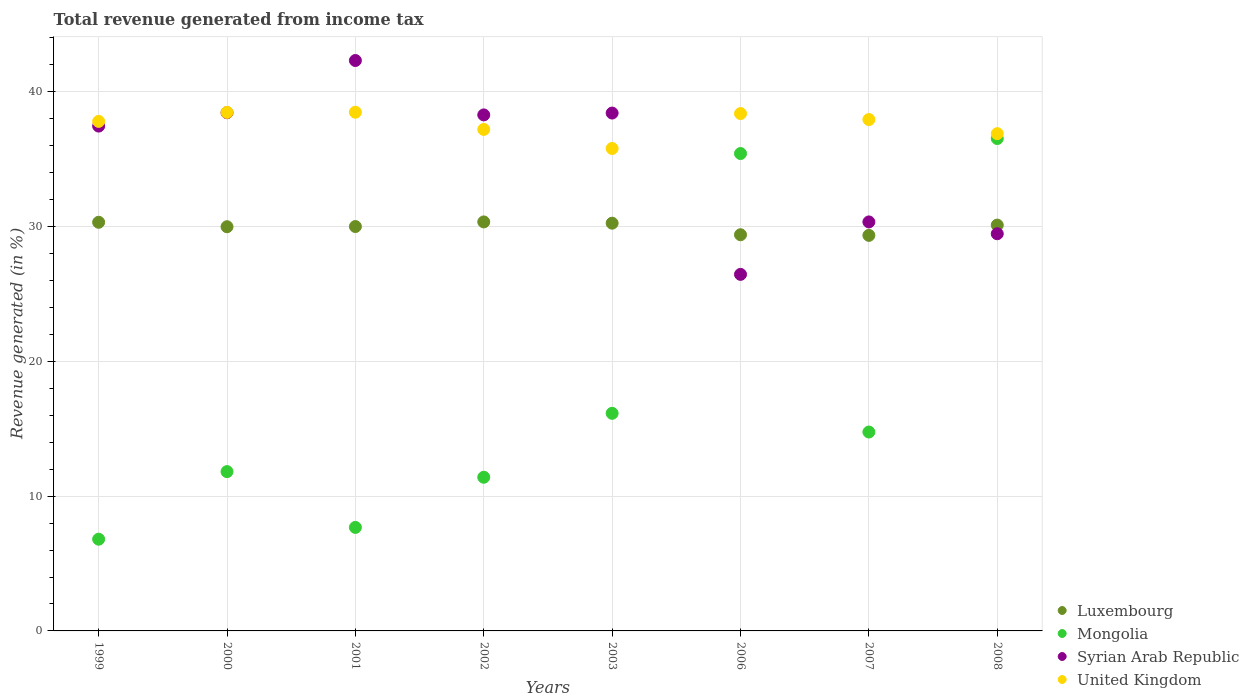How many different coloured dotlines are there?
Ensure brevity in your answer.  4. Is the number of dotlines equal to the number of legend labels?
Ensure brevity in your answer.  Yes. What is the total revenue generated in United Kingdom in 2002?
Your answer should be very brief. 37.2. Across all years, what is the maximum total revenue generated in Syrian Arab Republic?
Offer a very short reply. 42.32. Across all years, what is the minimum total revenue generated in Luxembourg?
Keep it short and to the point. 29.34. What is the total total revenue generated in Luxembourg in the graph?
Your answer should be compact. 239.73. What is the difference between the total revenue generated in Luxembourg in 2000 and that in 2007?
Offer a very short reply. 0.64. What is the difference between the total revenue generated in Mongolia in 2003 and the total revenue generated in Luxembourg in 2008?
Offer a terse response. -13.96. What is the average total revenue generated in Syrian Arab Republic per year?
Your response must be concise. 35.14. In the year 1999, what is the difference between the total revenue generated in Syrian Arab Republic and total revenue generated in Mongolia?
Keep it short and to the point. 30.65. What is the ratio of the total revenue generated in Syrian Arab Republic in 1999 to that in 2002?
Ensure brevity in your answer.  0.98. Is the difference between the total revenue generated in Syrian Arab Republic in 2000 and 2003 greater than the difference between the total revenue generated in Mongolia in 2000 and 2003?
Your response must be concise. Yes. What is the difference between the highest and the second highest total revenue generated in Luxembourg?
Make the answer very short. 0.03. What is the difference between the highest and the lowest total revenue generated in Luxembourg?
Provide a succinct answer. 1. In how many years, is the total revenue generated in Syrian Arab Republic greater than the average total revenue generated in Syrian Arab Republic taken over all years?
Your answer should be very brief. 5. Is the sum of the total revenue generated in Luxembourg in 1999 and 2001 greater than the maximum total revenue generated in Syrian Arab Republic across all years?
Provide a succinct answer. Yes. Is the total revenue generated in Luxembourg strictly less than the total revenue generated in Syrian Arab Republic over the years?
Offer a very short reply. No. How many dotlines are there?
Provide a short and direct response. 4. How are the legend labels stacked?
Provide a short and direct response. Vertical. What is the title of the graph?
Provide a succinct answer. Total revenue generated from income tax. Does "Northern Mariana Islands" appear as one of the legend labels in the graph?
Your answer should be very brief. No. What is the label or title of the Y-axis?
Offer a terse response. Revenue generated (in %). What is the Revenue generated (in %) in Luxembourg in 1999?
Ensure brevity in your answer.  30.32. What is the Revenue generated (in %) of Mongolia in 1999?
Ensure brevity in your answer.  6.8. What is the Revenue generated (in %) in Syrian Arab Republic in 1999?
Your response must be concise. 37.45. What is the Revenue generated (in %) in United Kingdom in 1999?
Make the answer very short. 37.8. What is the Revenue generated (in %) of Luxembourg in 2000?
Provide a succinct answer. 29.98. What is the Revenue generated (in %) of Mongolia in 2000?
Offer a very short reply. 11.82. What is the Revenue generated (in %) in Syrian Arab Republic in 2000?
Offer a terse response. 38.44. What is the Revenue generated (in %) in United Kingdom in 2000?
Provide a succinct answer. 38.46. What is the Revenue generated (in %) of Luxembourg in 2001?
Ensure brevity in your answer.  30. What is the Revenue generated (in %) of Mongolia in 2001?
Make the answer very short. 7.68. What is the Revenue generated (in %) of Syrian Arab Republic in 2001?
Offer a very short reply. 42.32. What is the Revenue generated (in %) in United Kingdom in 2001?
Give a very brief answer. 38.48. What is the Revenue generated (in %) of Luxembourg in 2002?
Offer a terse response. 30.34. What is the Revenue generated (in %) of Mongolia in 2002?
Make the answer very short. 11.4. What is the Revenue generated (in %) of Syrian Arab Republic in 2002?
Your answer should be compact. 38.28. What is the Revenue generated (in %) of United Kingdom in 2002?
Offer a terse response. 37.2. What is the Revenue generated (in %) in Luxembourg in 2003?
Your answer should be compact. 30.25. What is the Revenue generated (in %) of Mongolia in 2003?
Make the answer very short. 16.14. What is the Revenue generated (in %) in Syrian Arab Republic in 2003?
Provide a short and direct response. 38.42. What is the Revenue generated (in %) in United Kingdom in 2003?
Your response must be concise. 35.79. What is the Revenue generated (in %) of Luxembourg in 2006?
Your answer should be very brief. 29.39. What is the Revenue generated (in %) of Mongolia in 2006?
Keep it short and to the point. 35.41. What is the Revenue generated (in %) in Syrian Arab Republic in 2006?
Offer a very short reply. 26.45. What is the Revenue generated (in %) of United Kingdom in 2006?
Your answer should be compact. 38.38. What is the Revenue generated (in %) in Luxembourg in 2007?
Your answer should be very brief. 29.34. What is the Revenue generated (in %) of Mongolia in 2007?
Your answer should be compact. 14.75. What is the Revenue generated (in %) of Syrian Arab Republic in 2007?
Give a very brief answer. 30.34. What is the Revenue generated (in %) in United Kingdom in 2007?
Provide a succinct answer. 37.94. What is the Revenue generated (in %) of Luxembourg in 2008?
Provide a short and direct response. 30.11. What is the Revenue generated (in %) in Mongolia in 2008?
Keep it short and to the point. 36.53. What is the Revenue generated (in %) in Syrian Arab Republic in 2008?
Offer a terse response. 29.46. What is the Revenue generated (in %) of United Kingdom in 2008?
Offer a terse response. 36.89. Across all years, what is the maximum Revenue generated (in %) in Luxembourg?
Your response must be concise. 30.34. Across all years, what is the maximum Revenue generated (in %) of Mongolia?
Keep it short and to the point. 36.53. Across all years, what is the maximum Revenue generated (in %) in Syrian Arab Republic?
Keep it short and to the point. 42.32. Across all years, what is the maximum Revenue generated (in %) in United Kingdom?
Keep it short and to the point. 38.48. Across all years, what is the minimum Revenue generated (in %) of Luxembourg?
Provide a short and direct response. 29.34. Across all years, what is the minimum Revenue generated (in %) of Mongolia?
Provide a succinct answer. 6.8. Across all years, what is the minimum Revenue generated (in %) in Syrian Arab Republic?
Your answer should be very brief. 26.45. Across all years, what is the minimum Revenue generated (in %) in United Kingdom?
Provide a short and direct response. 35.79. What is the total Revenue generated (in %) in Luxembourg in the graph?
Provide a succinct answer. 239.73. What is the total Revenue generated (in %) of Mongolia in the graph?
Your answer should be very brief. 140.54. What is the total Revenue generated (in %) of Syrian Arab Republic in the graph?
Your response must be concise. 281.16. What is the total Revenue generated (in %) in United Kingdom in the graph?
Offer a terse response. 300.94. What is the difference between the Revenue generated (in %) in Luxembourg in 1999 and that in 2000?
Provide a short and direct response. 0.33. What is the difference between the Revenue generated (in %) of Mongolia in 1999 and that in 2000?
Ensure brevity in your answer.  -5.01. What is the difference between the Revenue generated (in %) in Syrian Arab Republic in 1999 and that in 2000?
Offer a terse response. -0.99. What is the difference between the Revenue generated (in %) of United Kingdom in 1999 and that in 2000?
Make the answer very short. -0.67. What is the difference between the Revenue generated (in %) in Luxembourg in 1999 and that in 2001?
Provide a short and direct response. 0.32. What is the difference between the Revenue generated (in %) in Mongolia in 1999 and that in 2001?
Offer a very short reply. -0.87. What is the difference between the Revenue generated (in %) in Syrian Arab Republic in 1999 and that in 2001?
Your answer should be compact. -4.86. What is the difference between the Revenue generated (in %) of United Kingdom in 1999 and that in 2001?
Provide a succinct answer. -0.68. What is the difference between the Revenue generated (in %) of Luxembourg in 1999 and that in 2002?
Provide a succinct answer. -0.03. What is the difference between the Revenue generated (in %) in Mongolia in 1999 and that in 2002?
Make the answer very short. -4.6. What is the difference between the Revenue generated (in %) in Syrian Arab Republic in 1999 and that in 2002?
Give a very brief answer. -0.83. What is the difference between the Revenue generated (in %) of United Kingdom in 1999 and that in 2002?
Offer a terse response. 0.6. What is the difference between the Revenue generated (in %) of Luxembourg in 1999 and that in 2003?
Your response must be concise. 0.07. What is the difference between the Revenue generated (in %) of Mongolia in 1999 and that in 2003?
Give a very brief answer. -9.34. What is the difference between the Revenue generated (in %) in Syrian Arab Republic in 1999 and that in 2003?
Provide a short and direct response. -0.97. What is the difference between the Revenue generated (in %) in United Kingdom in 1999 and that in 2003?
Ensure brevity in your answer.  2.01. What is the difference between the Revenue generated (in %) of Luxembourg in 1999 and that in 2006?
Keep it short and to the point. 0.92. What is the difference between the Revenue generated (in %) of Mongolia in 1999 and that in 2006?
Give a very brief answer. -28.61. What is the difference between the Revenue generated (in %) of Syrian Arab Republic in 1999 and that in 2006?
Offer a very short reply. 11. What is the difference between the Revenue generated (in %) of United Kingdom in 1999 and that in 2006?
Your answer should be very brief. -0.58. What is the difference between the Revenue generated (in %) in Luxembourg in 1999 and that in 2007?
Your response must be concise. 0.97. What is the difference between the Revenue generated (in %) in Mongolia in 1999 and that in 2007?
Your answer should be compact. -7.95. What is the difference between the Revenue generated (in %) in Syrian Arab Republic in 1999 and that in 2007?
Make the answer very short. 7.11. What is the difference between the Revenue generated (in %) in United Kingdom in 1999 and that in 2007?
Your response must be concise. -0.14. What is the difference between the Revenue generated (in %) in Luxembourg in 1999 and that in 2008?
Provide a succinct answer. 0.21. What is the difference between the Revenue generated (in %) of Mongolia in 1999 and that in 2008?
Your answer should be very brief. -29.72. What is the difference between the Revenue generated (in %) in Syrian Arab Republic in 1999 and that in 2008?
Your response must be concise. 7.99. What is the difference between the Revenue generated (in %) in United Kingdom in 1999 and that in 2008?
Provide a short and direct response. 0.91. What is the difference between the Revenue generated (in %) of Luxembourg in 2000 and that in 2001?
Ensure brevity in your answer.  -0.01. What is the difference between the Revenue generated (in %) in Mongolia in 2000 and that in 2001?
Offer a terse response. 4.14. What is the difference between the Revenue generated (in %) of Syrian Arab Republic in 2000 and that in 2001?
Offer a very short reply. -3.87. What is the difference between the Revenue generated (in %) of United Kingdom in 2000 and that in 2001?
Your answer should be very brief. -0.01. What is the difference between the Revenue generated (in %) in Luxembourg in 2000 and that in 2002?
Make the answer very short. -0.36. What is the difference between the Revenue generated (in %) of Mongolia in 2000 and that in 2002?
Your response must be concise. 0.42. What is the difference between the Revenue generated (in %) in Syrian Arab Republic in 2000 and that in 2002?
Provide a short and direct response. 0.16. What is the difference between the Revenue generated (in %) of United Kingdom in 2000 and that in 2002?
Your answer should be very brief. 1.26. What is the difference between the Revenue generated (in %) of Luxembourg in 2000 and that in 2003?
Your response must be concise. -0.26. What is the difference between the Revenue generated (in %) of Mongolia in 2000 and that in 2003?
Provide a succinct answer. -4.33. What is the difference between the Revenue generated (in %) of Syrian Arab Republic in 2000 and that in 2003?
Provide a succinct answer. 0.02. What is the difference between the Revenue generated (in %) of United Kingdom in 2000 and that in 2003?
Ensure brevity in your answer.  2.68. What is the difference between the Revenue generated (in %) of Luxembourg in 2000 and that in 2006?
Keep it short and to the point. 0.59. What is the difference between the Revenue generated (in %) of Mongolia in 2000 and that in 2006?
Give a very brief answer. -23.6. What is the difference between the Revenue generated (in %) in Syrian Arab Republic in 2000 and that in 2006?
Keep it short and to the point. 11.99. What is the difference between the Revenue generated (in %) of United Kingdom in 2000 and that in 2006?
Offer a terse response. 0.08. What is the difference between the Revenue generated (in %) of Luxembourg in 2000 and that in 2007?
Offer a very short reply. 0.64. What is the difference between the Revenue generated (in %) in Mongolia in 2000 and that in 2007?
Offer a very short reply. -2.94. What is the difference between the Revenue generated (in %) of Syrian Arab Republic in 2000 and that in 2007?
Give a very brief answer. 8.1. What is the difference between the Revenue generated (in %) in United Kingdom in 2000 and that in 2007?
Make the answer very short. 0.53. What is the difference between the Revenue generated (in %) in Luxembourg in 2000 and that in 2008?
Offer a terse response. -0.12. What is the difference between the Revenue generated (in %) of Mongolia in 2000 and that in 2008?
Provide a succinct answer. -24.71. What is the difference between the Revenue generated (in %) of Syrian Arab Republic in 2000 and that in 2008?
Make the answer very short. 8.98. What is the difference between the Revenue generated (in %) of United Kingdom in 2000 and that in 2008?
Give a very brief answer. 1.58. What is the difference between the Revenue generated (in %) in Luxembourg in 2001 and that in 2002?
Your answer should be compact. -0.34. What is the difference between the Revenue generated (in %) in Mongolia in 2001 and that in 2002?
Provide a succinct answer. -3.72. What is the difference between the Revenue generated (in %) of Syrian Arab Republic in 2001 and that in 2002?
Offer a very short reply. 4.04. What is the difference between the Revenue generated (in %) in United Kingdom in 2001 and that in 2002?
Provide a succinct answer. 1.28. What is the difference between the Revenue generated (in %) of Luxembourg in 2001 and that in 2003?
Provide a succinct answer. -0.25. What is the difference between the Revenue generated (in %) in Mongolia in 2001 and that in 2003?
Offer a very short reply. -8.46. What is the difference between the Revenue generated (in %) of Syrian Arab Republic in 2001 and that in 2003?
Make the answer very short. 3.9. What is the difference between the Revenue generated (in %) of United Kingdom in 2001 and that in 2003?
Your answer should be very brief. 2.69. What is the difference between the Revenue generated (in %) in Luxembourg in 2001 and that in 2006?
Your answer should be compact. 0.61. What is the difference between the Revenue generated (in %) of Mongolia in 2001 and that in 2006?
Keep it short and to the point. -27.74. What is the difference between the Revenue generated (in %) in Syrian Arab Republic in 2001 and that in 2006?
Keep it short and to the point. 15.87. What is the difference between the Revenue generated (in %) in United Kingdom in 2001 and that in 2006?
Keep it short and to the point. 0.1. What is the difference between the Revenue generated (in %) of Luxembourg in 2001 and that in 2007?
Your answer should be compact. 0.66. What is the difference between the Revenue generated (in %) in Mongolia in 2001 and that in 2007?
Offer a terse response. -7.08. What is the difference between the Revenue generated (in %) of Syrian Arab Republic in 2001 and that in 2007?
Provide a short and direct response. 11.97. What is the difference between the Revenue generated (in %) of United Kingdom in 2001 and that in 2007?
Provide a succinct answer. 0.54. What is the difference between the Revenue generated (in %) of Luxembourg in 2001 and that in 2008?
Provide a succinct answer. -0.11. What is the difference between the Revenue generated (in %) in Mongolia in 2001 and that in 2008?
Your answer should be compact. -28.85. What is the difference between the Revenue generated (in %) of Syrian Arab Republic in 2001 and that in 2008?
Make the answer very short. 12.85. What is the difference between the Revenue generated (in %) in United Kingdom in 2001 and that in 2008?
Your answer should be very brief. 1.59. What is the difference between the Revenue generated (in %) of Luxembourg in 2002 and that in 2003?
Provide a short and direct response. 0.09. What is the difference between the Revenue generated (in %) of Mongolia in 2002 and that in 2003?
Provide a short and direct response. -4.74. What is the difference between the Revenue generated (in %) in Syrian Arab Republic in 2002 and that in 2003?
Keep it short and to the point. -0.14. What is the difference between the Revenue generated (in %) in United Kingdom in 2002 and that in 2003?
Provide a succinct answer. 1.41. What is the difference between the Revenue generated (in %) of Luxembourg in 2002 and that in 2006?
Provide a succinct answer. 0.95. What is the difference between the Revenue generated (in %) in Mongolia in 2002 and that in 2006?
Provide a succinct answer. -24.01. What is the difference between the Revenue generated (in %) in Syrian Arab Republic in 2002 and that in 2006?
Your answer should be compact. 11.83. What is the difference between the Revenue generated (in %) in United Kingdom in 2002 and that in 2006?
Your response must be concise. -1.18. What is the difference between the Revenue generated (in %) of Mongolia in 2002 and that in 2007?
Make the answer very short. -3.36. What is the difference between the Revenue generated (in %) in Syrian Arab Republic in 2002 and that in 2007?
Provide a short and direct response. 7.94. What is the difference between the Revenue generated (in %) in United Kingdom in 2002 and that in 2007?
Your answer should be very brief. -0.73. What is the difference between the Revenue generated (in %) of Luxembourg in 2002 and that in 2008?
Give a very brief answer. 0.24. What is the difference between the Revenue generated (in %) of Mongolia in 2002 and that in 2008?
Make the answer very short. -25.13. What is the difference between the Revenue generated (in %) of Syrian Arab Republic in 2002 and that in 2008?
Provide a succinct answer. 8.82. What is the difference between the Revenue generated (in %) in United Kingdom in 2002 and that in 2008?
Your response must be concise. 0.31. What is the difference between the Revenue generated (in %) in Luxembourg in 2003 and that in 2006?
Your response must be concise. 0.86. What is the difference between the Revenue generated (in %) in Mongolia in 2003 and that in 2006?
Ensure brevity in your answer.  -19.27. What is the difference between the Revenue generated (in %) of Syrian Arab Republic in 2003 and that in 2006?
Keep it short and to the point. 11.97. What is the difference between the Revenue generated (in %) in United Kingdom in 2003 and that in 2006?
Make the answer very short. -2.59. What is the difference between the Revenue generated (in %) in Luxembourg in 2003 and that in 2007?
Offer a terse response. 0.9. What is the difference between the Revenue generated (in %) of Mongolia in 2003 and that in 2007?
Offer a very short reply. 1.39. What is the difference between the Revenue generated (in %) in Syrian Arab Republic in 2003 and that in 2007?
Give a very brief answer. 8.08. What is the difference between the Revenue generated (in %) of United Kingdom in 2003 and that in 2007?
Offer a very short reply. -2.15. What is the difference between the Revenue generated (in %) of Luxembourg in 2003 and that in 2008?
Give a very brief answer. 0.14. What is the difference between the Revenue generated (in %) of Mongolia in 2003 and that in 2008?
Provide a succinct answer. -20.39. What is the difference between the Revenue generated (in %) of Syrian Arab Republic in 2003 and that in 2008?
Offer a very short reply. 8.95. What is the difference between the Revenue generated (in %) of United Kingdom in 2003 and that in 2008?
Give a very brief answer. -1.1. What is the difference between the Revenue generated (in %) of Luxembourg in 2006 and that in 2007?
Keep it short and to the point. 0.05. What is the difference between the Revenue generated (in %) of Mongolia in 2006 and that in 2007?
Your response must be concise. 20.66. What is the difference between the Revenue generated (in %) in Syrian Arab Republic in 2006 and that in 2007?
Keep it short and to the point. -3.89. What is the difference between the Revenue generated (in %) of United Kingdom in 2006 and that in 2007?
Give a very brief answer. 0.44. What is the difference between the Revenue generated (in %) in Luxembourg in 2006 and that in 2008?
Offer a very short reply. -0.72. What is the difference between the Revenue generated (in %) in Mongolia in 2006 and that in 2008?
Provide a succinct answer. -1.11. What is the difference between the Revenue generated (in %) in Syrian Arab Republic in 2006 and that in 2008?
Offer a terse response. -3.01. What is the difference between the Revenue generated (in %) in United Kingdom in 2006 and that in 2008?
Provide a short and direct response. 1.49. What is the difference between the Revenue generated (in %) of Luxembourg in 2007 and that in 2008?
Your response must be concise. -0.76. What is the difference between the Revenue generated (in %) in Mongolia in 2007 and that in 2008?
Make the answer very short. -21.77. What is the difference between the Revenue generated (in %) in Syrian Arab Republic in 2007 and that in 2008?
Your answer should be very brief. 0.88. What is the difference between the Revenue generated (in %) of United Kingdom in 2007 and that in 2008?
Provide a succinct answer. 1.05. What is the difference between the Revenue generated (in %) in Luxembourg in 1999 and the Revenue generated (in %) in Mongolia in 2000?
Your answer should be very brief. 18.5. What is the difference between the Revenue generated (in %) in Luxembourg in 1999 and the Revenue generated (in %) in Syrian Arab Republic in 2000?
Make the answer very short. -8.13. What is the difference between the Revenue generated (in %) of Luxembourg in 1999 and the Revenue generated (in %) of United Kingdom in 2000?
Your answer should be very brief. -8.15. What is the difference between the Revenue generated (in %) of Mongolia in 1999 and the Revenue generated (in %) of Syrian Arab Republic in 2000?
Offer a very short reply. -31.64. What is the difference between the Revenue generated (in %) in Mongolia in 1999 and the Revenue generated (in %) in United Kingdom in 2000?
Your response must be concise. -31.66. What is the difference between the Revenue generated (in %) in Syrian Arab Republic in 1999 and the Revenue generated (in %) in United Kingdom in 2000?
Your response must be concise. -1.01. What is the difference between the Revenue generated (in %) of Luxembourg in 1999 and the Revenue generated (in %) of Mongolia in 2001?
Make the answer very short. 22.64. What is the difference between the Revenue generated (in %) in Luxembourg in 1999 and the Revenue generated (in %) in Syrian Arab Republic in 2001?
Keep it short and to the point. -12. What is the difference between the Revenue generated (in %) in Luxembourg in 1999 and the Revenue generated (in %) in United Kingdom in 2001?
Make the answer very short. -8.16. What is the difference between the Revenue generated (in %) of Mongolia in 1999 and the Revenue generated (in %) of Syrian Arab Republic in 2001?
Provide a succinct answer. -35.51. What is the difference between the Revenue generated (in %) in Mongolia in 1999 and the Revenue generated (in %) in United Kingdom in 2001?
Your response must be concise. -31.67. What is the difference between the Revenue generated (in %) in Syrian Arab Republic in 1999 and the Revenue generated (in %) in United Kingdom in 2001?
Provide a short and direct response. -1.03. What is the difference between the Revenue generated (in %) of Luxembourg in 1999 and the Revenue generated (in %) of Mongolia in 2002?
Provide a succinct answer. 18.92. What is the difference between the Revenue generated (in %) in Luxembourg in 1999 and the Revenue generated (in %) in Syrian Arab Republic in 2002?
Provide a succinct answer. -7.96. What is the difference between the Revenue generated (in %) of Luxembourg in 1999 and the Revenue generated (in %) of United Kingdom in 2002?
Your answer should be very brief. -6.89. What is the difference between the Revenue generated (in %) in Mongolia in 1999 and the Revenue generated (in %) in Syrian Arab Republic in 2002?
Make the answer very short. -31.48. What is the difference between the Revenue generated (in %) in Mongolia in 1999 and the Revenue generated (in %) in United Kingdom in 2002?
Provide a short and direct response. -30.4. What is the difference between the Revenue generated (in %) of Syrian Arab Republic in 1999 and the Revenue generated (in %) of United Kingdom in 2002?
Provide a short and direct response. 0.25. What is the difference between the Revenue generated (in %) of Luxembourg in 1999 and the Revenue generated (in %) of Mongolia in 2003?
Offer a very short reply. 14.17. What is the difference between the Revenue generated (in %) of Luxembourg in 1999 and the Revenue generated (in %) of Syrian Arab Republic in 2003?
Your answer should be compact. -8.1. What is the difference between the Revenue generated (in %) of Luxembourg in 1999 and the Revenue generated (in %) of United Kingdom in 2003?
Ensure brevity in your answer.  -5.47. What is the difference between the Revenue generated (in %) in Mongolia in 1999 and the Revenue generated (in %) in Syrian Arab Republic in 2003?
Offer a terse response. -31.61. What is the difference between the Revenue generated (in %) of Mongolia in 1999 and the Revenue generated (in %) of United Kingdom in 2003?
Give a very brief answer. -28.99. What is the difference between the Revenue generated (in %) of Syrian Arab Republic in 1999 and the Revenue generated (in %) of United Kingdom in 2003?
Provide a short and direct response. 1.66. What is the difference between the Revenue generated (in %) of Luxembourg in 1999 and the Revenue generated (in %) of Mongolia in 2006?
Make the answer very short. -5.1. What is the difference between the Revenue generated (in %) in Luxembourg in 1999 and the Revenue generated (in %) in Syrian Arab Republic in 2006?
Make the answer very short. 3.87. What is the difference between the Revenue generated (in %) in Luxembourg in 1999 and the Revenue generated (in %) in United Kingdom in 2006?
Your answer should be compact. -8.07. What is the difference between the Revenue generated (in %) in Mongolia in 1999 and the Revenue generated (in %) in Syrian Arab Republic in 2006?
Your answer should be compact. -19.65. What is the difference between the Revenue generated (in %) in Mongolia in 1999 and the Revenue generated (in %) in United Kingdom in 2006?
Ensure brevity in your answer.  -31.58. What is the difference between the Revenue generated (in %) in Syrian Arab Republic in 1999 and the Revenue generated (in %) in United Kingdom in 2006?
Offer a terse response. -0.93. What is the difference between the Revenue generated (in %) in Luxembourg in 1999 and the Revenue generated (in %) in Mongolia in 2007?
Provide a succinct answer. 15.56. What is the difference between the Revenue generated (in %) in Luxembourg in 1999 and the Revenue generated (in %) in Syrian Arab Republic in 2007?
Your response must be concise. -0.03. What is the difference between the Revenue generated (in %) in Luxembourg in 1999 and the Revenue generated (in %) in United Kingdom in 2007?
Your answer should be compact. -7.62. What is the difference between the Revenue generated (in %) in Mongolia in 1999 and the Revenue generated (in %) in Syrian Arab Republic in 2007?
Your answer should be compact. -23.54. What is the difference between the Revenue generated (in %) in Mongolia in 1999 and the Revenue generated (in %) in United Kingdom in 2007?
Make the answer very short. -31.13. What is the difference between the Revenue generated (in %) of Syrian Arab Republic in 1999 and the Revenue generated (in %) of United Kingdom in 2007?
Give a very brief answer. -0.49. What is the difference between the Revenue generated (in %) in Luxembourg in 1999 and the Revenue generated (in %) in Mongolia in 2008?
Your answer should be compact. -6.21. What is the difference between the Revenue generated (in %) in Luxembourg in 1999 and the Revenue generated (in %) in Syrian Arab Republic in 2008?
Your answer should be compact. 0.85. What is the difference between the Revenue generated (in %) in Luxembourg in 1999 and the Revenue generated (in %) in United Kingdom in 2008?
Offer a very short reply. -6.57. What is the difference between the Revenue generated (in %) of Mongolia in 1999 and the Revenue generated (in %) of Syrian Arab Republic in 2008?
Give a very brief answer. -22.66. What is the difference between the Revenue generated (in %) of Mongolia in 1999 and the Revenue generated (in %) of United Kingdom in 2008?
Offer a very short reply. -30.09. What is the difference between the Revenue generated (in %) of Syrian Arab Republic in 1999 and the Revenue generated (in %) of United Kingdom in 2008?
Your answer should be compact. 0.56. What is the difference between the Revenue generated (in %) of Luxembourg in 2000 and the Revenue generated (in %) of Mongolia in 2001?
Ensure brevity in your answer.  22.31. What is the difference between the Revenue generated (in %) of Luxembourg in 2000 and the Revenue generated (in %) of Syrian Arab Republic in 2001?
Provide a succinct answer. -12.33. What is the difference between the Revenue generated (in %) in Luxembourg in 2000 and the Revenue generated (in %) in United Kingdom in 2001?
Your answer should be very brief. -8.49. What is the difference between the Revenue generated (in %) of Mongolia in 2000 and the Revenue generated (in %) of Syrian Arab Republic in 2001?
Your answer should be compact. -30.5. What is the difference between the Revenue generated (in %) in Mongolia in 2000 and the Revenue generated (in %) in United Kingdom in 2001?
Your answer should be compact. -26.66. What is the difference between the Revenue generated (in %) in Syrian Arab Republic in 2000 and the Revenue generated (in %) in United Kingdom in 2001?
Make the answer very short. -0.04. What is the difference between the Revenue generated (in %) of Luxembourg in 2000 and the Revenue generated (in %) of Mongolia in 2002?
Keep it short and to the point. 18.59. What is the difference between the Revenue generated (in %) in Luxembourg in 2000 and the Revenue generated (in %) in Syrian Arab Republic in 2002?
Your answer should be very brief. -8.3. What is the difference between the Revenue generated (in %) in Luxembourg in 2000 and the Revenue generated (in %) in United Kingdom in 2002?
Give a very brief answer. -7.22. What is the difference between the Revenue generated (in %) in Mongolia in 2000 and the Revenue generated (in %) in Syrian Arab Republic in 2002?
Ensure brevity in your answer.  -26.46. What is the difference between the Revenue generated (in %) in Mongolia in 2000 and the Revenue generated (in %) in United Kingdom in 2002?
Keep it short and to the point. -25.39. What is the difference between the Revenue generated (in %) in Syrian Arab Republic in 2000 and the Revenue generated (in %) in United Kingdom in 2002?
Provide a succinct answer. 1.24. What is the difference between the Revenue generated (in %) of Luxembourg in 2000 and the Revenue generated (in %) of Mongolia in 2003?
Offer a very short reply. 13.84. What is the difference between the Revenue generated (in %) in Luxembourg in 2000 and the Revenue generated (in %) in Syrian Arab Republic in 2003?
Offer a very short reply. -8.43. What is the difference between the Revenue generated (in %) in Luxembourg in 2000 and the Revenue generated (in %) in United Kingdom in 2003?
Provide a succinct answer. -5.81. What is the difference between the Revenue generated (in %) of Mongolia in 2000 and the Revenue generated (in %) of Syrian Arab Republic in 2003?
Ensure brevity in your answer.  -26.6. What is the difference between the Revenue generated (in %) of Mongolia in 2000 and the Revenue generated (in %) of United Kingdom in 2003?
Ensure brevity in your answer.  -23.97. What is the difference between the Revenue generated (in %) in Syrian Arab Republic in 2000 and the Revenue generated (in %) in United Kingdom in 2003?
Your answer should be compact. 2.65. What is the difference between the Revenue generated (in %) in Luxembourg in 2000 and the Revenue generated (in %) in Mongolia in 2006?
Provide a short and direct response. -5.43. What is the difference between the Revenue generated (in %) of Luxembourg in 2000 and the Revenue generated (in %) of Syrian Arab Republic in 2006?
Offer a terse response. 3.53. What is the difference between the Revenue generated (in %) in Luxembourg in 2000 and the Revenue generated (in %) in United Kingdom in 2006?
Give a very brief answer. -8.4. What is the difference between the Revenue generated (in %) in Mongolia in 2000 and the Revenue generated (in %) in Syrian Arab Republic in 2006?
Your answer should be very brief. -14.63. What is the difference between the Revenue generated (in %) of Mongolia in 2000 and the Revenue generated (in %) of United Kingdom in 2006?
Ensure brevity in your answer.  -26.56. What is the difference between the Revenue generated (in %) in Syrian Arab Republic in 2000 and the Revenue generated (in %) in United Kingdom in 2006?
Offer a very short reply. 0.06. What is the difference between the Revenue generated (in %) of Luxembourg in 2000 and the Revenue generated (in %) of Mongolia in 2007?
Offer a very short reply. 15.23. What is the difference between the Revenue generated (in %) of Luxembourg in 2000 and the Revenue generated (in %) of Syrian Arab Republic in 2007?
Your response must be concise. -0.36. What is the difference between the Revenue generated (in %) of Luxembourg in 2000 and the Revenue generated (in %) of United Kingdom in 2007?
Give a very brief answer. -7.95. What is the difference between the Revenue generated (in %) in Mongolia in 2000 and the Revenue generated (in %) in Syrian Arab Republic in 2007?
Make the answer very short. -18.52. What is the difference between the Revenue generated (in %) of Mongolia in 2000 and the Revenue generated (in %) of United Kingdom in 2007?
Make the answer very short. -26.12. What is the difference between the Revenue generated (in %) of Syrian Arab Republic in 2000 and the Revenue generated (in %) of United Kingdom in 2007?
Offer a very short reply. 0.5. What is the difference between the Revenue generated (in %) of Luxembourg in 2000 and the Revenue generated (in %) of Mongolia in 2008?
Offer a very short reply. -6.54. What is the difference between the Revenue generated (in %) of Luxembourg in 2000 and the Revenue generated (in %) of Syrian Arab Republic in 2008?
Ensure brevity in your answer.  0.52. What is the difference between the Revenue generated (in %) of Luxembourg in 2000 and the Revenue generated (in %) of United Kingdom in 2008?
Offer a very short reply. -6.91. What is the difference between the Revenue generated (in %) in Mongolia in 2000 and the Revenue generated (in %) in Syrian Arab Republic in 2008?
Offer a terse response. -17.65. What is the difference between the Revenue generated (in %) in Mongolia in 2000 and the Revenue generated (in %) in United Kingdom in 2008?
Offer a terse response. -25.07. What is the difference between the Revenue generated (in %) in Syrian Arab Republic in 2000 and the Revenue generated (in %) in United Kingdom in 2008?
Ensure brevity in your answer.  1.55. What is the difference between the Revenue generated (in %) in Luxembourg in 2001 and the Revenue generated (in %) in Mongolia in 2002?
Give a very brief answer. 18.6. What is the difference between the Revenue generated (in %) of Luxembourg in 2001 and the Revenue generated (in %) of Syrian Arab Republic in 2002?
Your answer should be compact. -8.28. What is the difference between the Revenue generated (in %) in Luxembourg in 2001 and the Revenue generated (in %) in United Kingdom in 2002?
Provide a short and direct response. -7.2. What is the difference between the Revenue generated (in %) of Mongolia in 2001 and the Revenue generated (in %) of Syrian Arab Republic in 2002?
Provide a short and direct response. -30.6. What is the difference between the Revenue generated (in %) of Mongolia in 2001 and the Revenue generated (in %) of United Kingdom in 2002?
Ensure brevity in your answer.  -29.52. What is the difference between the Revenue generated (in %) of Syrian Arab Republic in 2001 and the Revenue generated (in %) of United Kingdom in 2002?
Keep it short and to the point. 5.11. What is the difference between the Revenue generated (in %) in Luxembourg in 2001 and the Revenue generated (in %) in Mongolia in 2003?
Your answer should be compact. 13.86. What is the difference between the Revenue generated (in %) in Luxembourg in 2001 and the Revenue generated (in %) in Syrian Arab Republic in 2003?
Provide a succinct answer. -8.42. What is the difference between the Revenue generated (in %) in Luxembourg in 2001 and the Revenue generated (in %) in United Kingdom in 2003?
Offer a very short reply. -5.79. What is the difference between the Revenue generated (in %) of Mongolia in 2001 and the Revenue generated (in %) of Syrian Arab Republic in 2003?
Ensure brevity in your answer.  -30.74. What is the difference between the Revenue generated (in %) in Mongolia in 2001 and the Revenue generated (in %) in United Kingdom in 2003?
Make the answer very short. -28.11. What is the difference between the Revenue generated (in %) of Syrian Arab Republic in 2001 and the Revenue generated (in %) of United Kingdom in 2003?
Provide a short and direct response. 6.53. What is the difference between the Revenue generated (in %) in Luxembourg in 2001 and the Revenue generated (in %) in Mongolia in 2006?
Offer a very short reply. -5.42. What is the difference between the Revenue generated (in %) in Luxembourg in 2001 and the Revenue generated (in %) in Syrian Arab Republic in 2006?
Provide a short and direct response. 3.55. What is the difference between the Revenue generated (in %) of Luxembourg in 2001 and the Revenue generated (in %) of United Kingdom in 2006?
Ensure brevity in your answer.  -8.38. What is the difference between the Revenue generated (in %) of Mongolia in 2001 and the Revenue generated (in %) of Syrian Arab Republic in 2006?
Give a very brief answer. -18.77. What is the difference between the Revenue generated (in %) in Mongolia in 2001 and the Revenue generated (in %) in United Kingdom in 2006?
Give a very brief answer. -30.7. What is the difference between the Revenue generated (in %) in Syrian Arab Republic in 2001 and the Revenue generated (in %) in United Kingdom in 2006?
Provide a succinct answer. 3.93. What is the difference between the Revenue generated (in %) in Luxembourg in 2001 and the Revenue generated (in %) in Mongolia in 2007?
Make the answer very short. 15.24. What is the difference between the Revenue generated (in %) of Luxembourg in 2001 and the Revenue generated (in %) of Syrian Arab Republic in 2007?
Your answer should be very brief. -0.34. What is the difference between the Revenue generated (in %) in Luxembourg in 2001 and the Revenue generated (in %) in United Kingdom in 2007?
Offer a terse response. -7.94. What is the difference between the Revenue generated (in %) of Mongolia in 2001 and the Revenue generated (in %) of Syrian Arab Republic in 2007?
Offer a very short reply. -22.66. What is the difference between the Revenue generated (in %) in Mongolia in 2001 and the Revenue generated (in %) in United Kingdom in 2007?
Offer a terse response. -30.26. What is the difference between the Revenue generated (in %) of Syrian Arab Republic in 2001 and the Revenue generated (in %) of United Kingdom in 2007?
Give a very brief answer. 4.38. What is the difference between the Revenue generated (in %) in Luxembourg in 2001 and the Revenue generated (in %) in Mongolia in 2008?
Offer a terse response. -6.53. What is the difference between the Revenue generated (in %) of Luxembourg in 2001 and the Revenue generated (in %) of Syrian Arab Republic in 2008?
Make the answer very short. 0.53. What is the difference between the Revenue generated (in %) of Luxembourg in 2001 and the Revenue generated (in %) of United Kingdom in 2008?
Offer a terse response. -6.89. What is the difference between the Revenue generated (in %) of Mongolia in 2001 and the Revenue generated (in %) of Syrian Arab Republic in 2008?
Provide a succinct answer. -21.79. What is the difference between the Revenue generated (in %) of Mongolia in 2001 and the Revenue generated (in %) of United Kingdom in 2008?
Keep it short and to the point. -29.21. What is the difference between the Revenue generated (in %) of Syrian Arab Republic in 2001 and the Revenue generated (in %) of United Kingdom in 2008?
Give a very brief answer. 5.43. What is the difference between the Revenue generated (in %) in Luxembourg in 2002 and the Revenue generated (in %) in Mongolia in 2003?
Your answer should be compact. 14.2. What is the difference between the Revenue generated (in %) in Luxembourg in 2002 and the Revenue generated (in %) in Syrian Arab Republic in 2003?
Your response must be concise. -8.07. What is the difference between the Revenue generated (in %) of Luxembourg in 2002 and the Revenue generated (in %) of United Kingdom in 2003?
Provide a succinct answer. -5.45. What is the difference between the Revenue generated (in %) of Mongolia in 2002 and the Revenue generated (in %) of Syrian Arab Republic in 2003?
Keep it short and to the point. -27.02. What is the difference between the Revenue generated (in %) of Mongolia in 2002 and the Revenue generated (in %) of United Kingdom in 2003?
Your response must be concise. -24.39. What is the difference between the Revenue generated (in %) of Syrian Arab Republic in 2002 and the Revenue generated (in %) of United Kingdom in 2003?
Offer a very short reply. 2.49. What is the difference between the Revenue generated (in %) in Luxembourg in 2002 and the Revenue generated (in %) in Mongolia in 2006?
Ensure brevity in your answer.  -5.07. What is the difference between the Revenue generated (in %) in Luxembourg in 2002 and the Revenue generated (in %) in Syrian Arab Republic in 2006?
Give a very brief answer. 3.89. What is the difference between the Revenue generated (in %) of Luxembourg in 2002 and the Revenue generated (in %) of United Kingdom in 2006?
Offer a very short reply. -8.04. What is the difference between the Revenue generated (in %) of Mongolia in 2002 and the Revenue generated (in %) of Syrian Arab Republic in 2006?
Offer a terse response. -15.05. What is the difference between the Revenue generated (in %) of Mongolia in 2002 and the Revenue generated (in %) of United Kingdom in 2006?
Give a very brief answer. -26.98. What is the difference between the Revenue generated (in %) in Syrian Arab Republic in 2002 and the Revenue generated (in %) in United Kingdom in 2006?
Your response must be concise. -0.1. What is the difference between the Revenue generated (in %) of Luxembourg in 2002 and the Revenue generated (in %) of Mongolia in 2007?
Your response must be concise. 15.59. What is the difference between the Revenue generated (in %) in Luxembourg in 2002 and the Revenue generated (in %) in Syrian Arab Republic in 2007?
Provide a short and direct response. 0. What is the difference between the Revenue generated (in %) in Luxembourg in 2002 and the Revenue generated (in %) in United Kingdom in 2007?
Keep it short and to the point. -7.59. What is the difference between the Revenue generated (in %) of Mongolia in 2002 and the Revenue generated (in %) of Syrian Arab Republic in 2007?
Keep it short and to the point. -18.94. What is the difference between the Revenue generated (in %) of Mongolia in 2002 and the Revenue generated (in %) of United Kingdom in 2007?
Give a very brief answer. -26.54. What is the difference between the Revenue generated (in %) of Syrian Arab Republic in 2002 and the Revenue generated (in %) of United Kingdom in 2007?
Your answer should be compact. 0.34. What is the difference between the Revenue generated (in %) in Luxembourg in 2002 and the Revenue generated (in %) in Mongolia in 2008?
Provide a succinct answer. -6.19. What is the difference between the Revenue generated (in %) of Luxembourg in 2002 and the Revenue generated (in %) of Syrian Arab Republic in 2008?
Your answer should be compact. 0.88. What is the difference between the Revenue generated (in %) of Luxembourg in 2002 and the Revenue generated (in %) of United Kingdom in 2008?
Your answer should be very brief. -6.55. What is the difference between the Revenue generated (in %) in Mongolia in 2002 and the Revenue generated (in %) in Syrian Arab Republic in 2008?
Provide a short and direct response. -18.06. What is the difference between the Revenue generated (in %) in Mongolia in 2002 and the Revenue generated (in %) in United Kingdom in 2008?
Your answer should be very brief. -25.49. What is the difference between the Revenue generated (in %) of Syrian Arab Republic in 2002 and the Revenue generated (in %) of United Kingdom in 2008?
Offer a terse response. 1.39. What is the difference between the Revenue generated (in %) in Luxembourg in 2003 and the Revenue generated (in %) in Mongolia in 2006?
Your answer should be compact. -5.17. What is the difference between the Revenue generated (in %) of Luxembourg in 2003 and the Revenue generated (in %) of Syrian Arab Republic in 2006?
Provide a succinct answer. 3.8. What is the difference between the Revenue generated (in %) in Luxembourg in 2003 and the Revenue generated (in %) in United Kingdom in 2006?
Keep it short and to the point. -8.13. What is the difference between the Revenue generated (in %) of Mongolia in 2003 and the Revenue generated (in %) of Syrian Arab Republic in 2006?
Ensure brevity in your answer.  -10.31. What is the difference between the Revenue generated (in %) in Mongolia in 2003 and the Revenue generated (in %) in United Kingdom in 2006?
Offer a terse response. -22.24. What is the difference between the Revenue generated (in %) in Syrian Arab Republic in 2003 and the Revenue generated (in %) in United Kingdom in 2006?
Keep it short and to the point. 0.04. What is the difference between the Revenue generated (in %) in Luxembourg in 2003 and the Revenue generated (in %) in Mongolia in 2007?
Offer a very short reply. 15.49. What is the difference between the Revenue generated (in %) of Luxembourg in 2003 and the Revenue generated (in %) of Syrian Arab Republic in 2007?
Make the answer very short. -0.09. What is the difference between the Revenue generated (in %) of Luxembourg in 2003 and the Revenue generated (in %) of United Kingdom in 2007?
Offer a very short reply. -7.69. What is the difference between the Revenue generated (in %) of Mongolia in 2003 and the Revenue generated (in %) of Syrian Arab Republic in 2007?
Keep it short and to the point. -14.2. What is the difference between the Revenue generated (in %) of Mongolia in 2003 and the Revenue generated (in %) of United Kingdom in 2007?
Your answer should be compact. -21.79. What is the difference between the Revenue generated (in %) in Syrian Arab Republic in 2003 and the Revenue generated (in %) in United Kingdom in 2007?
Give a very brief answer. 0.48. What is the difference between the Revenue generated (in %) of Luxembourg in 2003 and the Revenue generated (in %) of Mongolia in 2008?
Your answer should be very brief. -6.28. What is the difference between the Revenue generated (in %) in Luxembourg in 2003 and the Revenue generated (in %) in Syrian Arab Republic in 2008?
Keep it short and to the point. 0.78. What is the difference between the Revenue generated (in %) of Luxembourg in 2003 and the Revenue generated (in %) of United Kingdom in 2008?
Your response must be concise. -6.64. What is the difference between the Revenue generated (in %) in Mongolia in 2003 and the Revenue generated (in %) in Syrian Arab Republic in 2008?
Offer a very short reply. -13.32. What is the difference between the Revenue generated (in %) of Mongolia in 2003 and the Revenue generated (in %) of United Kingdom in 2008?
Offer a very short reply. -20.75. What is the difference between the Revenue generated (in %) of Syrian Arab Republic in 2003 and the Revenue generated (in %) of United Kingdom in 2008?
Provide a succinct answer. 1.53. What is the difference between the Revenue generated (in %) of Luxembourg in 2006 and the Revenue generated (in %) of Mongolia in 2007?
Provide a short and direct response. 14.64. What is the difference between the Revenue generated (in %) of Luxembourg in 2006 and the Revenue generated (in %) of Syrian Arab Republic in 2007?
Your answer should be very brief. -0.95. What is the difference between the Revenue generated (in %) in Luxembourg in 2006 and the Revenue generated (in %) in United Kingdom in 2007?
Your response must be concise. -8.55. What is the difference between the Revenue generated (in %) of Mongolia in 2006 and the Revenue generated (in %) of Syrian Arab Republic in 2007?
Provide a succinct answer. 5.07. What is the difference between the Revenue generated (in %) in Mongolia in 2006 and the Revenue generated (in %) in United Kingdom in 2007?
Offer a terse response. -2.52. What is the difference between the Revenue generated (in %) of Syrian Arab Republic in 2006 and the Revenue generated (in %) of United Kingdom in 2007?
Offer a terse response. -11.49. What is the difference between the Revenue generated (in %) in Luxembourg in 2006 and the Revenue generated (in %) in Mongolia in 2008?
Make the answer very short. -7.14. What is the difference between the Revenue generated (in %) in Luxembourg in 2006 and the Revenue generated (in %) in Syrian Arab Republic in 2008?
Keep it short and to the point. -0.07. What is the difference between the Revenue generated (in %) of Luxembourg in 2006 and the Revenue generated (in %) of United Kingdom in 2008?
Offer a terse response. -7.5. What is the difference between the Revenue generated (in %) in Mongolia in 2006 and the Revenue generated (in %) in Syrian Arab Republic in 2008?
Your answer should be compact. 5.95. What is the difference between the Revenue generated (in %) in Mongolia in 2006 and the Revenue generated (in %) in United Kingdom in 2008?
Provide a succinct answer. -1.48. What is the difference between the Revenue generated (in %) of Syrian Arab Republic in 2006 and the Revenue generated (in %) of United Kingdom in 2008?
Provide a succinct answer. -10.44. What is the difference between the Revenue generated (in %) in Luxembourg in 2007 and the Revenue generated (in %) in Mongolia in 2008?
Your response must be concise. -7.18. What is the difference between the Revenue generated (in %) in Luxembourg in 2007 and the Revenue generated (in %) in Syrian Arab Republic in 2008?
Provide a succinct answer. -0.12. What is the difference between the Revenue generated (in %) in Luxembourg in 2007 and the Revenue generated (in %) in United Kingdom in 2008?
Provide a short and direct response. -7.55. What is the difference between the Revenue generated (in %) of Mongolia in 2007 and the Revenue generated (in %) of Syrian Arab Republic in 2008?
Make the answer very short. -14.71. What is the difference between the Revenue generated (in %) of Mongolia in 2007 and the Revenue generated (in %) of United Kingdom in 2008?
Provide a succinct answer. -22.14. What is the difference between the Revenue generated (in %) in Syrian Arab Republic in 2007 and the Revenue generated (in %) in United Kingdom in 2008?
Provide a short and direct response. -6.55. What is the average Revenue generated (in %) in Luxembourg per year?
Your answer should be compact. 29.97. What is the average Revenue generated (in %) in Mongolia per year?
Provide a succinct answer. 17.57. What is the average Revenue generated (in %) in Syrian Arab Republic per year?
Provide a succinct answer. 35.14. What is the average Revenue generated (in %) in United Kingdom per year?
Ensure brevity in your answer.  37.62. In the year 1999, what is the difference between the Revenue generated (in %) of Luxembourg and Revenue generated (in %) of Mongolia?
Your response must be concise. 23.51. In the year 1999, what is the difference between the Revenue generated (in %) in Luxembourg and Revenue generated (in %) in Syrian Arab Republic?
Your answer should be compact. -7.14. In the year 1999, what is the difference between the Revenue generated (in %) in Luxembourg and Revenue generated (in %) in United Kingdom?
Ensure brevity in your answer.  -7.48. In the year 1999, what is the difference between the Revenue generated (in %) of Mongolia and Revenue generated (in %) of Syrian Arab Republic?
Ensure brevity in your answer.  -30.65. In the year 1999, what is the difference between the Revenue generated (in %) of Mongolia and Revenue generated (in %) of United Kingdom?
Give a very brief answer. -30.99. In the year 1999, what is the difference between the Revenue generated (in %) of Syrian Arab Republic and Revenue generated (in %) of United Kingdom?
Your answer should be very brief. -0.35. In the year 2000, what is the difference between the Revenue generated (in %) of Luxembourg and Revenue generated (in %) of Mongolia?
Your response must be concise. 18.17. In the year 2000, what is the difference between the Revenue generated (in %) of Luxembourg and Revenue generated (in %) of Syrian Arab Republic?
Your response must be concise. -8.46. In the year 2000, what is the difference between the Revenue generated (in %) in Luxembourg and Revenue generated (in %) in United Kingdom?
Your answer should be compact. -8.48. In the year 2000, what is the difference between the Revenue generated (in %) of Mongolia and Revenue generated (in %) of Syrian Arab Republic?
Your answer should be very brief. -26.62. In the year 2000, what is the difference between the Revenue generated (in %) of Mongolia and Revenue generated (in %) of United Kingdom?
Keep it short and to the point. -26.65. In the year 2000, what is the difference between the Revenue generated (in %) of Syrian Arab Republic and Revenue generated (in %) of United Kingdom?
Provide a succinct answer. -0.02. In the year 2001, what is the difference between the Revenue generated (in %) in Luxembourg and Revenue generated (in %) in Mongolia?
Your answer should be very brief. 22.32. In the year 2001, what is the difference between the Revenue generated (in %) in Luxembourg and Revenue generated (in %) in Syrian Arab Republic?
Keep it short and to the point. -12.32. In the year 2001, what is the difference between the Revenue generated (in %) of Luxembourg and Revenue generated (in %) of United Kingdom?
Provide a succinct answer. -8.48. In the year 2001, what is the difference between the Revenue generated (in %) of Mongolia and Revenue generated (in %) of Syrian Arab Republic?
Your answer should be compact. -34.64. In the year 2001, what is the difference between the Revenue generated (in %) in Mongolia and Revenue generated (in %) in United Kingdom?
Offer a terse response. -30.8. In the year 2001, what is the difference between the Revenue generated (in %) in Syrian Arab Republic and Revenue generated (in %) in United Kingdom?
Your response must be concise. 3.84. In the year 2002, what is the difference between the Revenue generated (in %) of Luxembourg and Revenue generated (in %) of Mongolia?
Your response must be concise. 18.94. In the year 2002, what is the difference between the Revenue generated (in %) in Luxembourg and Revenue generated (in %) in Syrian Arab Republic?
Your response must be concise. -7.94. In the year 2002, what is the difference between the Revenue generated (in %) of Luxembourg and Revenue generated (in %) of United Kingdom?
Offer a very short reply. -6.86. In the year 2002, what is the difference between the Revenue generated (in %) of Mongolia and Revenue generated (in %) of Syrian Arab Republic?
Your response must be concise. -26.88. In the year 2002, what is the difference between the Revenue generated (in %) in Mongolia and Revenue generated (in %) in United Kingdom?
Your answer should be compact. -25.8. In the year 2002, what is the difference between the Revenue generated (in %) in Syrian Arab Republic and Revenue generated (in %) in United Kingdom?
Keep it short and to the point. 1.08. In the year 2003, what is the difference between the Revenue generated (in %) in Luxembourg and Revenue generated (in %) in Mongolia?
Keep it short and to the point. 14.1. In the year 2003, what is the difference between the Revenue generated (in %) in Luxembourg and Revenue generated (in %) in Syrian Arab Republic?
Offer a terse response. -8.17. In the year 2003, what is the difference between the Revenue generated (in %) of Luxembourg and Revenue generated (in %) of United Kingdom?
Your answer should be very brief. -5.54. In the year 2003, what is the difference between the Revenue generated (in %) of Mongolia and Revenue generated (in %) of Syrian Arab Republic?
Offer a terse response. -22.27. In the year 2003, what is the difference between the Revenue generated (in %) in Mongolia and Revenue generated (in %) in United Kingdom?
Give a very brief answer. -19.65. In the year 2003, what is the difference between the Revenue generated (in %) of Syrian Arab Republic and Revenue generated (in %) of United Kingdom?
Provide a succinct answer. 2.63. In the year 2006, what is the difference between the Revenue generated (in %) in Luxembourg and Revenue generated (in %) in Mongolia?
Give a very brief answer. -6.02. In the year 2006, what is the difference between the Revenue generated (in %) of Luxembourg and Revenue generated (in %) of Syrian Arab Republic?
Offer a terse response. 2.94. In the year 2006, what is the difference between the Revenue generated (in %) of Luxembourg and Revenue generated (in %) of United Kingdom?
Your answer should be very brief. -8.99. In the year 2006, what is the difference between the Revenue generated (in %) in Mongolia and Revenue generated (in %) in Syrian Arab Republic?
Offer a very short reply. 8.96. In the year 2006, what is the difference between the Revenue generated (in %) in Mongolia and Revenue generated (in %) in United Kingdom?
Keep it short and to the point. -2.97. In the year 2006, what is the difference between the Revenue generated (in %) in Syrian Arab Republic and Revenue generated (in %) in United Kingdom?
Give a very brief answer. -11.93. In the year 2007, what is the difference between the Revenue generated (in %) of Luxembourg and Revenue generated (in %) of Mongolia?
Provide a short and direct response. 14.59. In the year 2007, what is the difference between the Revenue generated (in %) of Luxembourg and Revenue generated (in %) of Syrian Arab Republic?
Make the answer very short. -1. In the year 2007, what is the difference between the Revenue generated (in %) in Luxembourg and Revenue generated (in %) in United Kingdom?
Your response must be concise. -8.59. In the year 2007, what is the difference between the Revenue generated (in %) in Mongolia and Revenue generated (in %) in Syrian Arab Republic?
Provide a succinct answer. -15.59. In the year 2007, what is the difference between the Revenue generated (in %) of Mongolia and Revenue generated (in %) of United Kingdom?
Provide a short and direct response. -23.18. In the year 2007, what is the difference between the Revenue generated (in %) of Syrian Arab Republic and Revenue generated (in %) of United Kingdom?
Ensure brevity in your answer.  -7.6. In the year 2008, what is the difference between the Revenue generated (in %) of Luxembourg and Revenue generated (in %) of Mongolia?
Make the answer very short. -6.42. In the year 2008, what is the difference between the Revenue generated (in %) of Luxembourg and Revenue generated (in %) of Syrian Arab Republic?
Keep it short and to the point. 0.64. In the year 2008, what is the difference between the Revenue generated (in %) in Luxembourg and Revenue generated (in %) in United Kingdom?
Offer a terse response. -6.78. In the year 2008, what is the difference between the Revenue generated (in %) of Mongolia and Revenue generated (in %) of Syrian Arab Republic?
Your response must be concise. 7.06. In the year 2008, what is the difference between the Revenue generated (in %) of Mongolia and Revenue generated (in %) of United Kingdom?
Your response must be concise. -0.36. In the year 2008, what is the difference between the Revenue generated (in %) of Syrian Arab Republic and Revenue generated (in %) of United Kingdom?
Make the answer very short. -7.43. What is the ratio of the Revenue generated (in %) in Luxembourg in 1999 to that in 2000?
Your answer should be compact. 1.01. What is the ratio of the Revenue generated (in %) in Mongolia in 1999 to that in 2000?
Ensure brevity in your answer.  0.58. What is the ratio of the Revenue generated (in %) in Syrian Arab Republic in 1999 to that in 2000?
Ensure brevity in your answer.  0.97. What is the ratio of the Revenue generated (in %) of United Kingdom in 1999 to that in 2000?
Give a very brief answer. 0.98. What is the ratio of the Revenue generated (in %) of Luxembourg in 1999 to that in 2001?
Provide a succinct answer. 1.01. What is the ratio of the Revenue generated (in %) of Mongolia in 1999 to that in 2001?
Your response must be concise. 0.89. What is the ratio of the Revenue generated (in %) in Syrian Arab Republic in 1999 to that in 2001?
Offer a terse response. 0.89. What is the ratio of the Revenue generated (in %) in United Kingdom in 1999 to that in 2001?
Your answer should be compact. 0.98. What is the ratio of the Revenue generated (in %) in Luxembourg in 1999 to that in 2002?
Your response must be concise. 1. What is the ratio of the Revenue generated (in %) in Mongolia in 1999 to that in 2002?
Keep it short and to the point. 0.6. What is the ratio of the Revenue generated (in %) of Syrian Arab Republic in 1999 to that in 2002?
Offer a very short reply. 0.98. What is the ratio of the Revenue generated (in %) in Mongolia in 1999 to that in 2003?
Offer a terse response. 0.42. What is the ratio of the Revenue generated (in %) of Syrian Arab Republic in 1999 to that in 2003?
Make the answer very short. 0.97. What is the ratio of the Revenue generated (in %) of United Kingdom in 1999 to that in 2003?
Your answer should be very brief. 1.06. What is the ratio of the Revenue generated (in %) of Luxembourg in 1999 to that in 2006?
Keep it short and to the point. 1.03. What is the ratio of the Revenue generated (in %) in Mongolia in 1999 to that in 2006?
Offer a terse response. 0.19. What is the ratio of the Revenue generated (in %) of Syrian Arab Republic in 1999 to that in 2006?
Your answer should be compact. 1.42. What is the ratio of the Revenue generated (in %) in United Kingdom in 1999 to that in 2006?
Your answer should be very brief. 0.98. What is the ratio of the Revenue generated (in %) in Luxembourg in 1999 to that in 2007?
Make the answer very short. 1.03. What is the ratio of the Revenue generated (in %) in Mongolia in 1999 to that in 2007?
Your response must be concise. 0.46. What is the ratio of the Revenue generated (in %) in Syrian Arab Republic in 1999 to that in 2007?
Offer a terse response. 1.23. What is the ratio of the Revenue generated (in %) of Luxembourg in 1999 to that in 2008?
Your answer should be very brief. 1.01. What is the ratio of the Revenue generated (in %) of Mongolia in 1999 to that in 2008?
Your response must be concise. 0.19. What is the ratio of the Revenue generated (in %) of Syrian Arab Republic in 1999 to that in 2008?
Your answer should be compact. 1.27. What is the ratio of the Revenue generated (in %) of United Kingdom in 1999 to that in 2008?
Provide a short and direct response. 1.02. What is the ratio of the Revenue generated (in %) of Luxembourg in 2000 to that in 2001?
Offer a very short reply. 1. What is the ratio of the Revenue generated (in %) in Mongolia in 2000 to that in 2001?
Keep it short and to the point. 1.54. What is the ratio of the Revenue generated (in %) of Syrian Arab Republic in 2000 to that in 2001?
Make the answer very short. 0.91. What is the ratio of the Revenue generated (in %) in Mongolia in 2000 to that in 2002?
Ensure brevity in your answer.  1.04. What is the ratio of the Revenue generated (in %) in Syrian Arab Republic in 2000 to that in 2002?
Provide a succinct answer. 1. What is the ratio of the Revenue generated (in %) in United Kingdom in 2000 to that in 2002?
Offer a very short reply. 1.03. What is the ratio of the Revenue generated (in %) in Luxembourg in 2000 to that in 2003?
Give a very brief answer. 0.99. What is the ratio of the Revenue generated (in %) in Mongolia in 2000 to that in 2003?
Make the answer very short. 0.73. What is the ratio of the Revenue generated (in %) of Syrian Arab Republic in 2000 to that in 2003?
Your response must be concise. 1. What is the ratio of the Revenue generated (in %) of United Kingdom in 2000 to that in 2003?
Your answer should be very brief. 1.07. What is the ratio of the Revenue generated (in %) of Luxembourg in 2000 to that in 2006?
Offer a very short reply. 1.02. What is the ratio of the Revenue generated (in %) in Mongolia in 2000 to that in 2006?
Offer a very short reply. 0.33. What is the ratio of the Revenue generated (in %) of Syrian Arab Republic in 2000 to that in 2006?
Make the answer very short. 1.45. What is the ratio of the Revenue generated (in %) of United Kingdom in 2000 to that in 2006?
Make the answer very short. 1. What is the ratio of the Revenue generated (in %) of Luxembourg in 2000 to that in 2007?
Ensure brevity in your answer.  1.02. What is the ratio of the Revenue generated (in %) in Mongolia in 2000 to that in 2007?
Make the answer very short. 0.8. What is the ratio of the Revenue generated (in %) in Syrian Arab Republic in 2000 to that in 2007?
Your response must be concise. 1.27. What is the ratio of the Revenue generated (in %) of United Kingdom in 2000 to that in 2007?
Provide a succinct answer. 1.01. What is the ratio of the Revenue generated (in %) in Luxembourg in 2000 to that in 2008?
Offer a very short reply. 1. What is the ratio of the Revenue generated (in %) of Mongolia in 2000 to that in 2008?
Give a very brief answer. 0.32. What is the ratio of the Revenue generated (in %) in Syrian Arab Republic in 2000 to that in 2008?
Your answer should be very brief. 1.3. What is the ratio of the Revenue generated (in %) of United Kingdom in 2000 to that in 2008?
Provide a short and direct response. 1.04. What is the ratio of the Revenue generated (in %) of Luxembourg in 2001 to that in 2002?
Keep it short and to the point. 0.99. What is the ratio of the Revenue generated (in %) in Mongolia in 2001 to that in 2002?
Provide a succinct answer. 0.67. What is the ratio of the Revenue generated (in %) of Syrian Arab Republic in 2001 to that in 2002?
Provide a succinct answer. 1.11. What is the ratio of the Revenue generated (in %) of United Kingdom in 2001 to that in 2002?
Offer a very short reply. 1.03. What is the ratio of the Revenue generated (in %) of Mongolia in 2001 to that in 2003?
Make the answer very short. 0.48. What is the ratio of the Revenue generated (in %) in Syrian Arab Republic in 2001 to that in 2003?
Provide a short and direct response. 1.1. What is the ratio of the Revenue generated (in %) of United Kingdom in 2001 to that in 2003?
Offer a terse response. 1.08. What is the ratio of the Revenue generated (in %) of Luxembourg in 2001 to that in 2006?
Your answer should be very brief. 1.02. What is the ratio of the Revenue generated (in %) of Mongolia in 2001 to that in 2006?
Keep it short and to the point. 0.22. What is the ratio of the Revenue generated (in %) in Syrian Arab Republic in 2001 to that in 2006?
Your answer should be compact. 1.6. What is the ratio of the Revenue generated (in %) of Luxembourg in 2001 to that in 2007?
Your answer should be compact. 1.02. What is the ratio of the Revenue generated (in %) in Mongolia in 2001 to that in 2007?
Your answer should be very brief. 0.52. What is the ratio of the Revenue generated (in %) of Syrian Arab Republic in 2001 to that in 2007?
Offer a very short reply. 1.39. What is the ratio of the Revenue generated (in %) in United Kingdom in 2001 to that in 2007?
Provide a short and direct response. 1.01. What is the ratio of the Revenue generated (in %) in Luxembourg in 2001 to that in 2008?
Your answer should be compact. 1. What is the ratio of the Revenue generated (in %) in Mongolia in 2001 to that in 2008?
Provide a succinct answer. 0.21. What is the ratio of the Revenue generated (in %) in Syrian Arab Republic in 2001 to that in 2008?
Your answer should be very brief. 1.44. What is the ratio of the Revenue generated (in %) in United Kingdom in 2001 to that in 2008?
Provide a short and direct response. 1.04. What is the ratio of the Revenue generated (in %) in Mongolia in 2002 to that in 2003?
Your answer should be very brief. 0.71. What is the ratio of the Revenue generated (in %) in Syrian Arab Republic in 2002 to that in 2003?
Make the answer very short. 1. What is the ratio of the Revenue generated (in %) of United Kingdom in 2002 to that in 2003?
Your response must be concise. 1.04. What is the ratio of the Revenue generated (in %) of Luxembourg in 2002 to that in 2006?
Your answer should be very brief. 1.03. What is the ratio of the Revenue generated (in %) of Mongolia in 2002 to that in 2006?
Ensure brevity in your answer.  0.32. What is the ratio of the Revenue generated (in %) of Syrian Arab Republic in 2002 to that in 2006?
Give a very brief answer. 1.45. What is the ratio of the Revenue generated (in %) in United Kingdom in 2002 to that in 2006?
Give a very brief answer. 0.97. What is the ratio of the Revenue generated (in %) of Luxembourg in 2002 to that in 2007?
Make the answer very short. 1.03. What is the ratio of the Revenue generated (in %) of Mongolia in 2002 to that in 2007?
Keep it short and to the point. 0.77. What is the ratio of the Revenue generated (in %) of Syrian Arab Republic in 2002 to that in 2007?
Your response must be concise. 1.26. What is the ratio of the Revenue generated (in %) of United Kingdom in 2002 to that in 2007?
Your answer should be very brief. 0.98. What is the ratio of the Revenue generated (in %) in Luxembourg in 2002 to that in 2008?
Ensure brevity in your answer.  1.01. What is the ratio of the Revenue generated (in %) in Mongolia in 2002 to that in 2008?
Give a very brief answer. 0.31. What is the ratio of the Revenue generated (in %) in Syrian Arab Republic in 2002 to that in 2008?
Offer a very short reply. 1.3. What is the ratio of the Revenue generated (in %) in United Kingdom in 2002 to that in 2008?
Your answer should be compact. 1.01. What is the ratio of the Revenue generated (in %) of Luxembourg in 2003 to that in 2006?
Keep it short and to the point. 1.03. What is the ratio of the Revenue generated (in %) of Mongolia in 2003 to that in 2006?
Offer a very short reply. 0.46. What is the ratio of the Revenue generated (in %) of Syrian Arab Republic in 2003 to that in 2006?
Provide a succinct answer. 1.45. What is the ratio of the Revenue generated (in %) in United Kingdom in 2003 to that in 2006?
Your answer should be compact. 0.93. What is the ratio of the Revenue generated (in %) in Luxembourg in 2003 to that in 2007?
Ensure brevity in your answer.  1.03. What is the ratio of the Revenue generated (in %) in Mongolia in 2003 to that in 2007?
Provide a succinct answer. 1.09. What is the ratio of the Revenue generated (in %) in Syrian Arab Republic in 2003 to that in 2007?
Give a very brief answer. 1.27. What is the ratio of the Revenue generated (in %) of United Kingdom in 2003 to that in 2007?
Make the answer very short. 0.94. What is the ratio of the Revenue generated (in %) of Mongolia in 2003 to that in 2008?
Give a very brief answer. 0.44. What is the ratio of the Revenue generated (in %) in Syrian Arab Republic in 2003 to that in 2008?
Provide a succinct answer. 1.3. What is the ratio of the Revenue generated (in %) of United Kingdom in 2003 to that in 2008?
Give a very brief answer. 0.97. What is the ratio of the Revenue generated (in %) of Luxembourg in 2006 to that in 2007?
Provide a succinct answer. 1. What is the ratio of the Revenue generated (in %) in Mongolia in 2006 to that in 2007?
Offer a terse response. 2.4. What is the ratio of the Revenue generated (in %) in Syrian Arab Republic in 2006 to that in 2007?
Offer a very short reply. 0.87. What is the ratio of the Revenue generated (in %) in United Kingdom in 2006 to that in 2007?
Provide a short and direct response. 1.01. What is the ratio of the Revenue generated (in %) of Luxembourg in 2006 to that in 2008?
Make the answer very short. 0.98. What is the ratio of the Revenue generated (in %) in Mongolia in 2006 to that in 2008?
Make the answer very short. 0.97. What is the ratio of the Revenue generated (in %) of Syrian Arab Republic in 2006 to that in 2008?
Ensure brevity in your answer.  0.9. What is the ratio of the Revenue generated (in %) in United Kingdom in 2006 to that in 2008?
Make the answer very short. 1.04. What is the ratio of the Revenue generated (in %) in Luxembourg in 2007 to that in 2008?
Offer a terse response. 0.97. What is the ratio of the Revenue generated (in %) in Mongolia in 2007 to that in 2008?
Keep it short and to the point. 0.4. What is the ratio of the Revenue generated (in %) in Syrian Arab Republic in 2007 to that in 2008?
Offer a very short reply. 1.03. What is the ratio of the Revenue generated (in %) in United Kingdom in 2007 to that in 2008?
Keep it short and to the point. 1.03. What is the difference between the highest and the second highest Revenue generated (in %) of Luxembourg?
Make the answer very short. 0.03. What is the difference between the highest and the second highest Revenue generated (in %) of Mongolia?
Your answer should be very brief. 1.11. What is the difference between the highest and the second highest Revenue generated (in %) in Syrian Arab Republic?
Provide a succinct answer. 3.87. What is the difference between the highest and the second highest Revenue generated (in %) in United Kingdom?
Provide a succinct answer. 0.01. What is the difference between the highest and the lowest Revenue generated (in %) of Luxembourg?
Your answer should be compact. 1. What is the difference between the highest and the lowest Revenue generated (in %) in Mongolia?
Your answer should be very brief. 29.72. What is the difference between the highest and the lowest Revenue generated (in %) of Syrian Arab Republic?
Keep it short and to the point. 15.87. What is the difference between the highest and the lowest Revenue generated (in %) in United Kingdom?
Offer a very short reply. 2.69. 